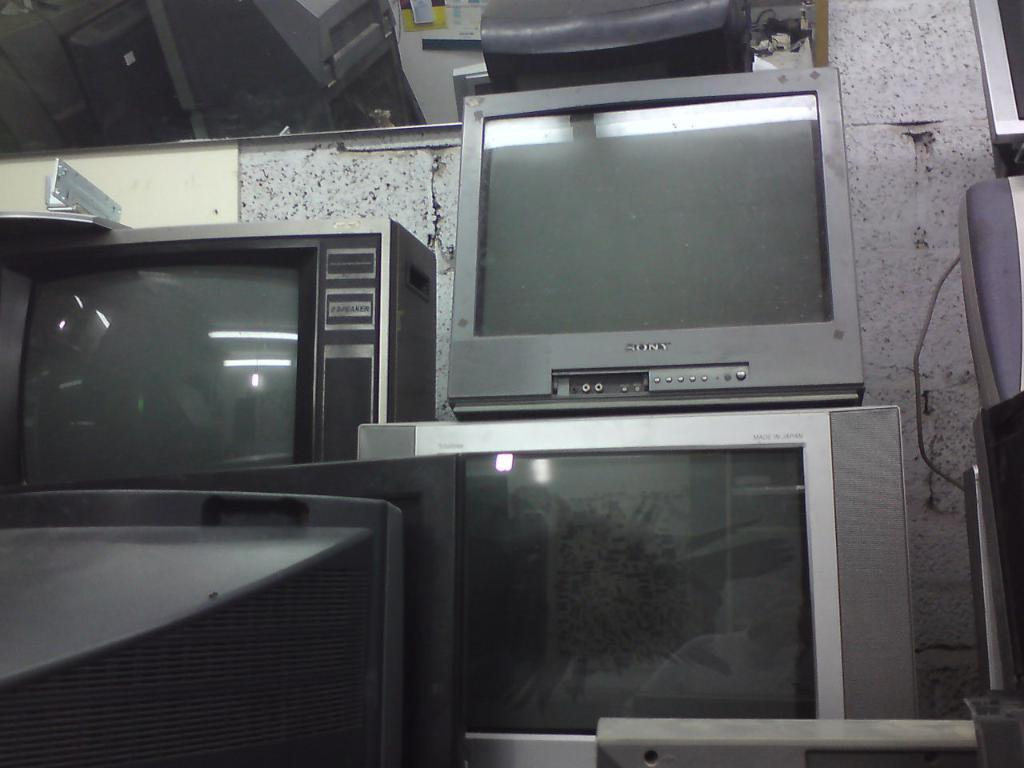<image>
Describe the image concisely. A silver Sony brand television sits atop another TV. 